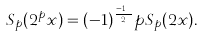Convert formula to latex. <formula><loc_0><loc_0><loc_500><loc_500>S _ { p } ( 2 ^ { p } x ) = ( - 1 ) ^ { \frac { p - 1 } { 2 } } p S _ { p } ( 2 x ) .</formula> 